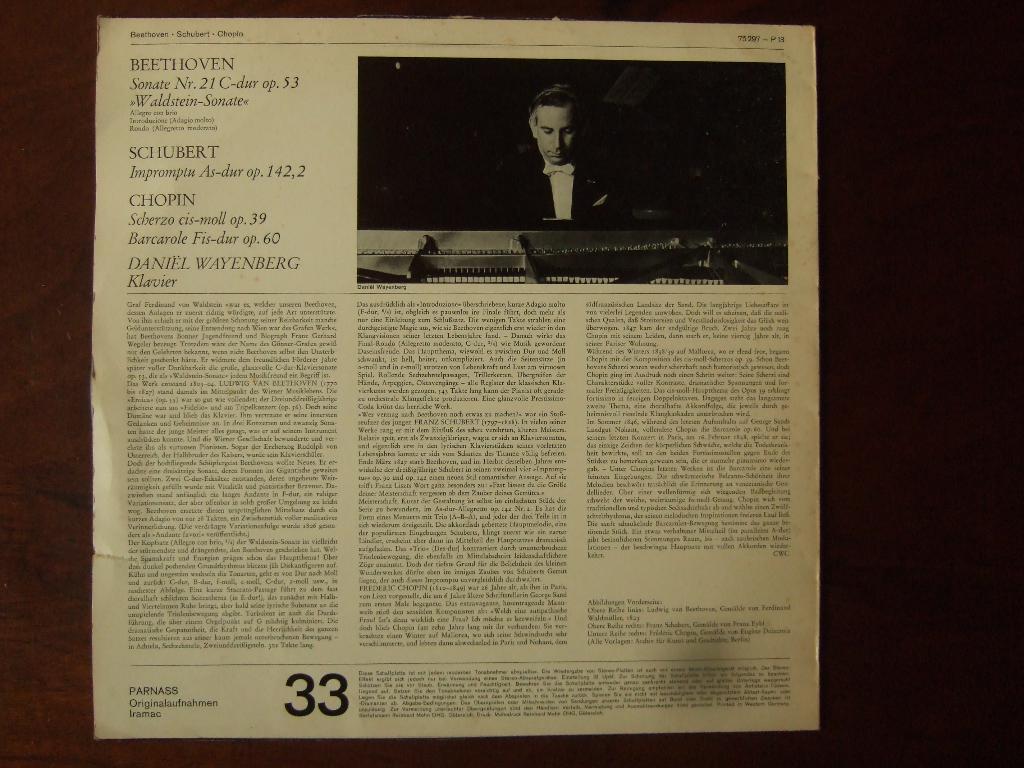How would you summarize this image in a sentence or two? There is a paper on a surface. There is an image of a person at the right top. Below that matter is written. At the bottom ''33'' is written in bold font. 